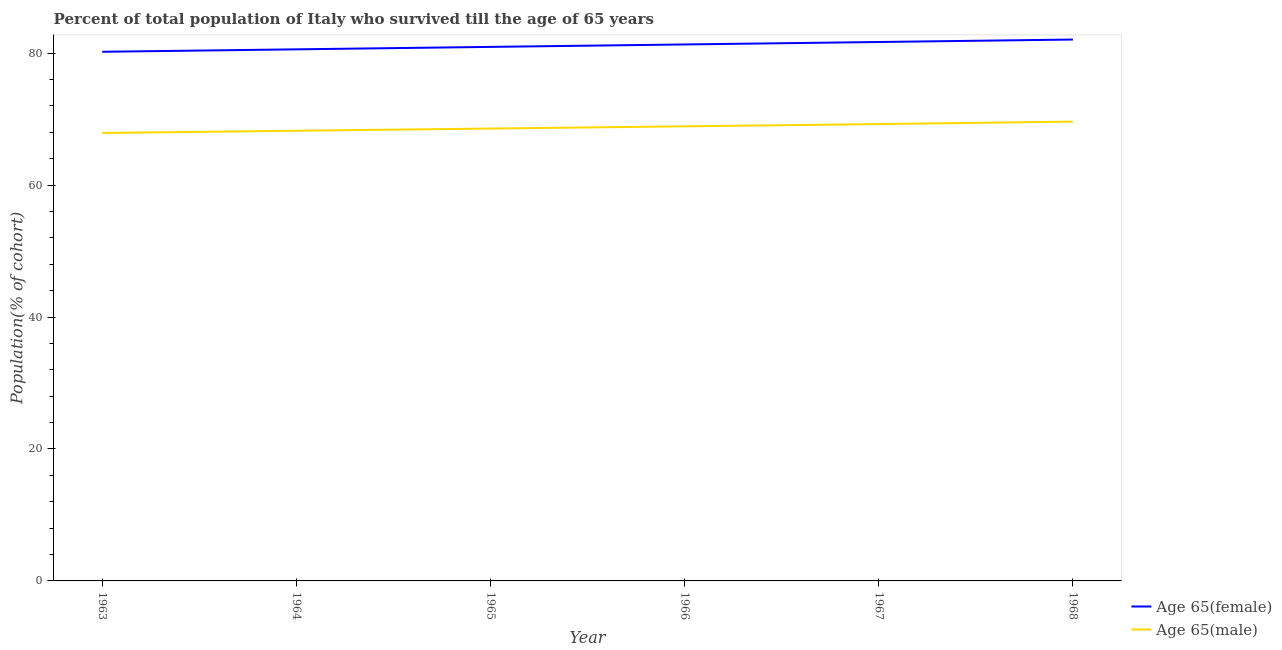Does the line corresponding to percentage of male population who survived till age of 65 intersect with the line corresponding to percentage of female population who survived till age of 65?
Ensure brevity in your answer.  No. What is the percentage of male population who survived till age of 65 in 1965?
Your answer should be very brief. 68.57. Across all years, what is the maximum percentage of female population who survived till age of 65?
Provide a short and direct response. 82.06. Across all years, what is the minimum percentage of male population who survived till age of 65?
Your answer should be compact. 67.9. In which year was the percentage of male population who survived till age of 65 maximum?
Give a very brief answer. 1968. What is the total percentage of female population who survived till age of 65 in the graph?
Your answer should be very brief. 486.8. What is the difference between the percentage of female population who survived till age of 65 in 1966 and that in 1967?
Your response must be concise. -0.37. What is the difference between the percentage of female population who survived till age of 65 in 1967 and the percentage of male population who survived till age of 65 in 1968?
Make the answer very short. 12.07. What is the average percentage of female population who survived till age of 65 per year?
Your answer should be compact. 81.13. In the year 1968, what is the difference between the percentage of male population who survived till age of 65 and percentage of female population who survived till age of 65?
Your answer should be very brief. -12.44. What is the ratio of the percentage of male population who survived till age of 65 in 1963 to that in 1964?
Ensure brevity in your answer.  1. Is the percentage of female population who survived till age of 65 in 1963 less than that in 1966?
Your response must be concise. Yes. Is the difference between the percentage of male population who survived till age of 65 in 1966 and 1967 greater than the difference between the percentage of female population who survived till age of 65 in 1966 and 1967?
Keep it short and to the point. Yes. What is the difference between the highest and the second highest percentage of male population who survived till age of 65?
Offer a very short reply. 0.38. What is the difference between the highest and the lowest percentage of female population who survived till age of 65?
Give a very brief answer. 1.86. Is the percentage of female population who survived till age of 65 strictly greater than the percentage of male population who survived till age of 65 over the years?
Your answer should be very brief. Yes. Is the percentage of male population who survived till age of 65 strictly less than the percentage of female population who survived till age of 65 over the years?
Your answer should be compact. Yes. Are the values on the major ticks of Y-axis written in scientific E-notation?
Your answer should be very brief. No. Does the graph contain any zero values?
Give a very brief answer. No. Does the graph contain grids?
Your answer should be compact. No. What is the title of the graph?
Your response must be concise. Percent of total population of Italy who survived till the age of 65 years. What is the label or title of the X-axis?
Your answer should be compact. Year. What is the label or title of the Y-axis?
Keep it short and to the point. Population(% of cohort). What is the Population(% of cohort) in Age 65(female) in 1963?
Offer a terse response. 80.21. What is the Population(% of cohort) in Age 65(male) in 1963?
Your response must be concise. 67.9. What is the Population(% of cohort) of Age 65(female) in 1964?
Provide a short and direct response. 80.58. What is the Population(% of cohort) of Age 65(male) in 1964?
Ensure brevity in your answer.  68.24. What is the Population(% of cohort) of Age 65(female) in 1965?
Offer a terse response. 80.95. What is the Population(% of cohort) in Age 65(male) in 1965?
Provide a short and direct response. 68.57. What is the Population(% of cohort) of Age 65(female) in 1966?
Your response must be concise. 81.32. What is the Population(% of cohort) of Age 65(male) in 1966?
Provide a short and direct response. 68.91. What is the Population(% of cohort) of Age 65(female) in 1967?
Provide a short and direct response. 81.69. What is the Population(% of cohort) of Age 65(male) in 1967?
Keep it short and to the point. 69.24. What is the Population(% of cohort) of Age 65(female) in 1968?
Give a very brief answer. 82.06. What is the Population(% of cohort) in Age 65(male) in 1968?
Your response must be concise. 69.62. Across all years, what is the maximum Population(% of cohort) of Age 65(female)?
Your answer should be very brief. 82.06. Across all years, what is the maximum Population(% of cohort) of Age 65(male)?
Offer a very short reply. 69.62. Across all years, what is the minimum Population(% of cohort) in Age 65(female)?
Your response must be concise. 80.21. Across all years, what is the minimum Population(% of cohort) in Age 65(male)?
Your answer should be very brief. 67.9. What is the total Population(% of cohort) of Age 65(female) in the graph?
Provide a succinct answer. 486.8. What is the total Population(% of cohort) in Age 65(male) in the graph?
Keep it short and to the point. 412.48. What is the difference between the Population(% of cohort) in Age 65(female) in 1963 and that in 1964?
Keep it short and to the point. -0.37. What is the difference between the Population(% of cohort) in Age 65(male) in 1963 and that in 1964?
Provide a succinct answer. -0.34. What is the difference between the Population(% of cohort) in Age 65(female) in 1963 and that in 1965?
Your answer should be compact. -0.74. What is the difference between the Population(% of cohort) of Age 65(male) in 1963 and that in 1965?
Offer a terse response. -0.67. What is the difference between the Population(% of cohort) of Age 65(female) in 1963 and that in 1966?
Your response must be concise. -1.11. What is the difference between the Population(% of cohort) of Age 65(male) in 1963 and that in 1966?
Your response must be concise. -1.01. What is the difference between the Population(% of cohort) of Age 65(female) in 1963 and that in 1967?
Your answer should be very brief. -1.48. What is the difference between the Population(% of cohort) of Age 65(male) in 1963 and that in 1967?
Provide a short and direct response. -1.34. What is the difference between the Population(% of cohort) of Age 65(female) in 1963 and that in 1968?
Your answer should be compact. -1.86. What is the difference between the Population(% of cohort) of Age 65(male) in 1963 and that in 1968?
Keep it short and to the point. -1.72. What is the difference between the Population(% of cohort) of Age 65(female) in 1964 and that in 1965?
Provide a short and direct response. -0.37. What is the difference between the Population(% of cohort) of Age 65(male) in 1964 and that in 1965?
Your response must be concise. -0.34. What is the difference between the Population(% of cohort) in Age 65(female) in 1964 and that in 1966?
Provide a short and direct response. -0.74. What is the difference between the Population(% of cohort) in Age 65(male) in 1964 and that in 1966?
Your response must be concise. -0.67. What is the difference between the Population(% of cohort) in Age 65(female) in 1964 and that in 1967?
Give a very brief answer. -1.11. What is the difference between the Population(% of cohort) in Age 65(male) in 1964 and that in 1967?
Your answer should be compact. -1.01. What is the difference between the Population(% of cohort) in Age 65(female) in 1964 and that in 1968?
Give a very brief answer. -1.49. What is the difference between the Population(% of cohort) of Age 65(male) in 1964 and that in 1968?
Your answer should be compact. -1.39. What is the difference between the Population(% of cohort) in Age 65(female) in 1965 and that in 1966?
Provide a succinct answer. -0.37. What is the difference between the Population(% of cohort) of Age 65(male) in 1965 and that in 1966?
Keep it short and to the point. -0.34. What is the difference between the Population(% of cohort) in Age 65(female) in 1965 and that in 1967?
Your answer should be very brief. -0.74. What is the difference between the Population(% of cohort) in Age 65(male) in 1965 and that in 1967?
Offer a very short reply. -0.67. What is the difference between the Population(% of cohort) of Age 65(female) in 1965 and that in 1968?
Offer a very short reply. -1.11. What is the difference between the Population(% of cohort) in Age 65(male) in 1965 and that in 1968?
Your answer should be very brief. -1.05. What is the difference between the Population(% of cohort) in Age 65(female) in 1966 and that in 1967?
Offer a very short reply. -0.37. What is the difference between the Population(% of cohort) in Age 65(male) in 1966 and that in 1967?
Give a very brief answer. -0.34. What is the difference between the Population(% of cohort) of Age 65(female) in 1966 and that in 1968?
Keep it short and to the point. -0.74. What is the difference between the Population(% of cohort) in Age 65(male) in 1966 and that in 1968?
Your answer should be very brief. -0.72. What is the difference between the Population(% of cohort) of Age 65(female) in 1967 and that in 1968?
Offer a terse response. -0.37. What is the difference between the Population(% of cohort) in Age 65(male) in 1967 and that in 1968?
Make the answer very short. -0.38. What is the difference between the Population(% of cohort) of Age 65(female) in 1963 and the Population(% of cohort) of Age 65(male) in 1964?
Your response must be concise. 11.97. What is the difference between the Population(% of cohort) in Age 65(female) in 1963 and the Population(% of cohort) in Age 65(male) in 1965?
Your answer should be compact. 11.63. What is the difference between the Population(% of cohort) in Age 65(female) in 1963 and the Population(% of cohort) in Age 65(male) in 1966?
Your answer should be very brief. 11.3. What is the difference between the Population(% of cohort) of Age 65(female) in 1963 and the Population(% of cohort) of Age 65(male) in 1967?
Offer a terse response. 10.96. What is the difference between the Population(% of cohort) of Age 65(female) in 1963 and the Population(% of cohort) of Age 65(male) in 1968?
Your answer should be very brief. 10.58. What is the difference between the Population(% of cohort) in Age 65(female) in 1964 and the Population(% of cohort) in Age 65(male) in 1965?
Give a very brief answer. 12.01. What is the difference between the Population(% of cohort) of Age 65(female) in 1964 and the Population(% of cohort) of Age 65(male) in 1966?
Offer a terse response. 11.67. What is the difference between the Population(% of cohort) in Age 65(female) in 1964 and the Population(% of cohort) in Age 65(male) in 1967?
Your answer should be compact. 11.33. What is the difference between the Population(% of cohort) in Age 65(female) in 1964 and the Population(% of cohort) in Age 65(male) in 1968?
Make the answer very short. 10.95. What is the difference between the Population(% of cohort) of Age 65(female) in 1965 and the Population(% of cohort) of Age 65(male) in 1966?
Offer a terse response. 12.04. What is the difference between the Population(% of cohort) of Age 65(female) in 1965 and the Population(% of cohort) of Age 65(male) in 1967?
Provide a succinct answer. 11.71. What is the difference between the Population(% of cohort) in Age 65(female) in 1965 and the Population(% of cohort) in Age 65(male) in 1968?
Your answer should be very brief. 11.32. What is the difference between the Population(% of cohort) of Age 65(female) in 1966 and the Population(% of cohort) of Age 65(male) in 1967?
Your response must be concise. 12.08. What is the difference between the Population(% of cohort) of Age 65(female) in 1966 and the Population(% of cohort) of Age 65(male) in 1968?
Your answer should be very brief. 11.69. What is the difference between the Population(% of cohort) of Age 65(female) in 1967 and the Population(% of cohort) of Age 65(male) in 1968?
Provide a succinct answer. 12.07. What is the average Population(% of cohort) in Age 65(female) per year?
Your answer should be very brief. 81.13. What is the average Population(% of cohort) in Age 65(male) per year?
Give a very brief answer. 68.75. In the year 1963, what is the difference between the Population(% of cohort) of Age 65(female) and Population(% of cohort) of Age 65(male)?
Provide a succinct answer. 12.3. In the year 1964, what is the difference between the Population(% of cohort) of Age 65(female) and Population(% of cohort) of Age 65(male)?
Provide a succinct answer. 12.34. In the year 1965, what is the difference between the Population(% of cohort) of Age 65(female) and Population(% of cohort) of Age 65(male)?
Offer a terse response. 12.38. In the year 1966, what is the difference between the Population(% of cohort) of Age 65(female) and Population(% of cohort) of Age 65(male)?
Your answer should be very brief. 12.41. In the year 1967, what is the difference between the Population(% of cohort) in Age 65(female) and Population(% of cohort) in Age 65(male)?
Your response must be concise. 12.45. In the year 1968, what is the difference between the Population(% of cohort) of Age 65(female) and Population(% of cohort) of Age 65(male)?
Your response must be concise. 12.44. What is the ratio of the Population(% of cohort) of Age 65(male) in 1963 to that in 1964?
Give a very brief answer. 1. What is the ratio of the Population(% of cohort) of Age 65(male) in 1963 to that in 1965?
Ensure brevity in your answer.  0.99. What is the ratio of the Population(% of cohort) in Age 65(female) in 1963 to that in 1966?
Make the answer very short. 0.99. What is the ratio of the Population(% of cohort) in Age 65(male) in 1963 to that in 1966?
Provide a short and direct response. 0.99. What is the ratio of the Population(% of cohort) in Age 65(female) in 1963 to that in 1967?
Your answer should be compact. 0.98. What is the ratio of the Population(% of cohort) of Age 65(male) in 1963 to that in 1967?
Offer a terse response. 0.98. What is the ratio of the Population(% of cohort) in Age 65(female) in 1963 to that in 1968?
Offer a terse response. 0.98. What is the ratio of the Population(% of cohort) of Age 65(male) in 1963 to that in 1968?
Keep it short and to the point. 0.98. What is the ratio of the Population(% of cohort) of Age 65(female) in 1964 to that in 1965?
Ensure brevity in your answer.  1. What is the ratio of the Population(% of cohort) in Age 65(female) in 1964 to that in 1966?
Your response must be concise. 0.99. What is the ratio of the Population(% of cohort) of Age 65(male) in 1964 to that in 1966?
Your response must be concise. 0.99. What is the ratio of the Population(% of cohort) of Age 65(female) in 1964 to that in 1967?
Offer a terse response. 0.99. What is the ratio of the Population(% of cohort) of Age 65(male) in 1964 to that in 1967?
Offer a terse response. 0.99. What is the ratio of the Population(% of cohort) in Age 65(female) in 1964 to that in 1968?
Offer a terse response. 0.98. What is the ratio of the Population(% of cohort) in Age 65(male) in 1964 to that in 1968?
Provide a succinct answer. 0.98. What is the ratio of the Population(% of cohort) of Age 65(male) in 1965 to that in 1966?
Keep it short and to the point. 1. What is the ratio of the Population(% of cohort) in Age 65(female) in 1965 to that in 1967?
Offer a terse response. 0.99. What is the ratio of the Population(% of cohort) of Age 65(male) in 1965 to that in 1967?
Offer a very short reply. 0.99. What is the ratio of the Population(% of cohort) of Age 65(female) in 1965 to that in 1968?
Your answer should be compact. 0.99. What is the ratio of the Population(% of cohort) in Age 65(male) in 1965 to that in 1968?
Provide a succinct answer. 0.98. What is the ratio of the Population(% of cohort) of Age 65(female) in 1966 to that in 1967?
Give a very brief answer. 1. What is the ratio of the Population(% of cohort) in Age 65(male) in 1966 to that in 1967?
Your response must be concise. 1. What is the ratio of the Population(% of cohort) in Age 65(female) in 1966 to that in 1968?
Your answer should be very brief. 0.99. What is the ratio of the Population(% of cohort) of Age 65(male) in 1966 to that in 1968?
Offer a terse response. 0.99. What is the ratio of the Population(% of cohort) of Age 65(male) in 1967 to that in 1968?
Offer a very short reply. 0.99. What is the difference between the highest and the second highest Population(% of cohort) in Age 65(female)?
Offer a terse response. 0.37. What is the difference between the highest and the second highest Population(% of cohort) in Age 65(male)?
Make the answer very short. 0.38. What is the difference between the highest and the lowest Population(% of cohort) of Age 65(female)?
Keep it short and to the point. 1.86. What is the difference between the highest and the lowest Population(% of cohort) in Age 65(male)?
Provide a succinct answer. 1.72. 